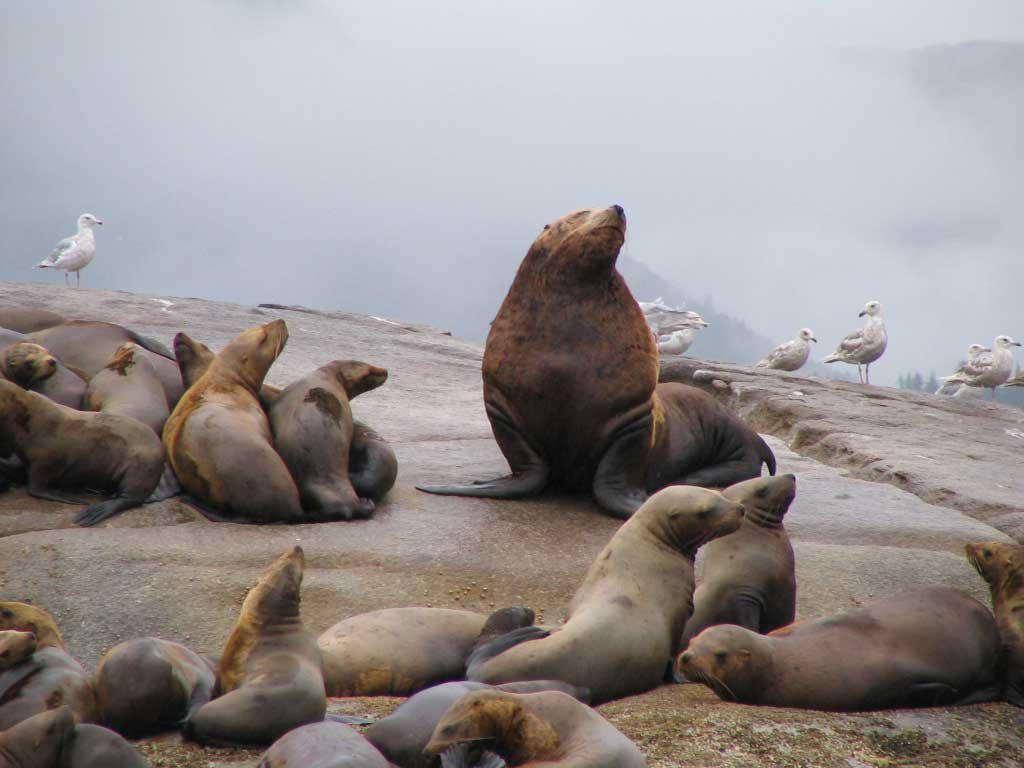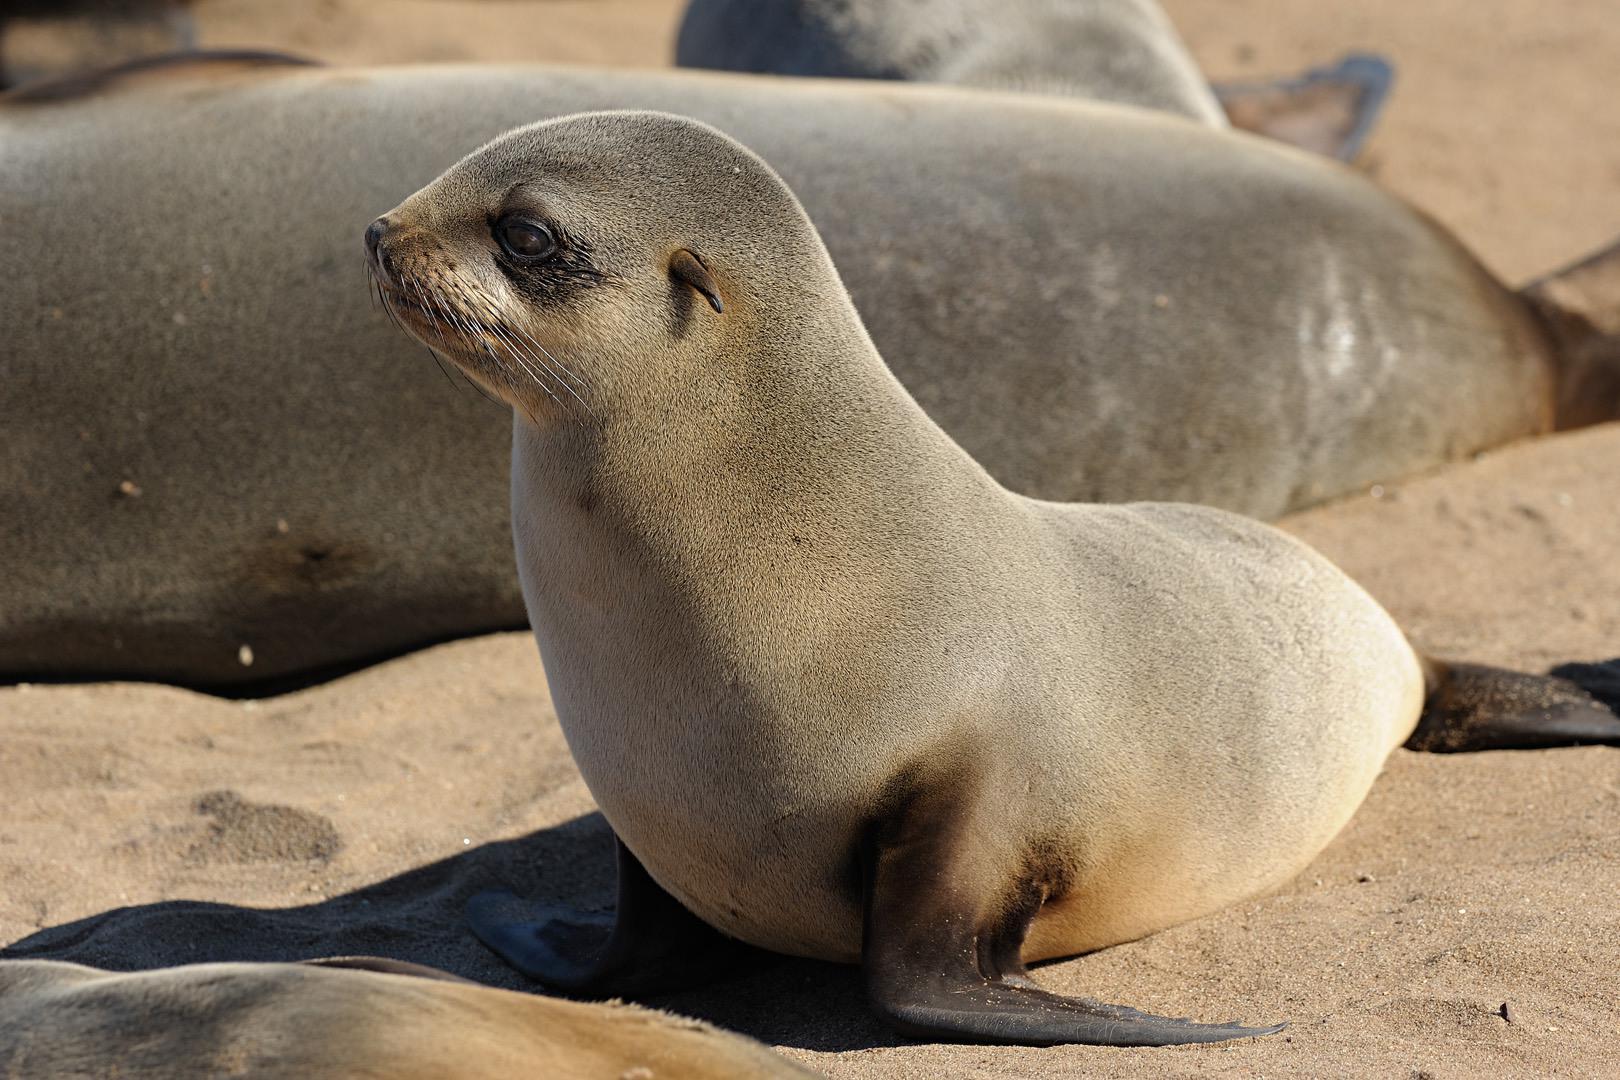The first image is the image on the left, the second image is the image on the right. For the images shown, is this caption "An image shows just one seal in the foreground, who is facing left." true? Answer yes or no. Yes. The first image is the image on the left, the second image is the image on the right. Evaluate the accuracy of this statement regarding the images: "the background is hazy in the image on the left". Is it true? Answer yes or no. Yes. 